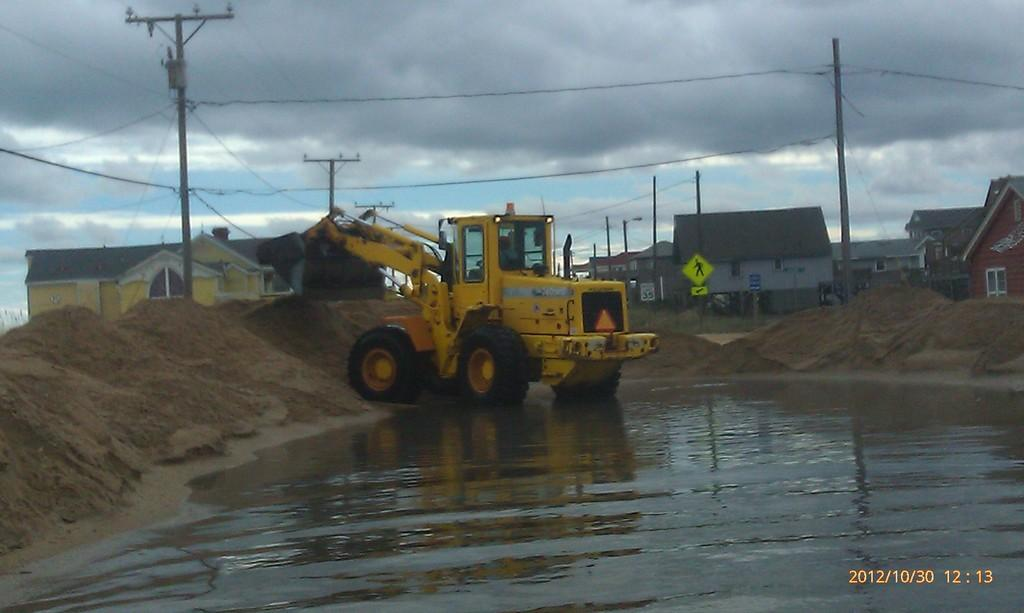<image>
Describe the image concisely. A tractor moves some dirt on October 30, 2012. 